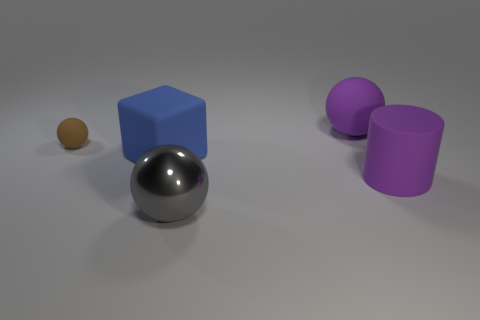Are there any other things that have the same material as the gray thing? Upon inspecting the image, it appears that the gray sphere has a reflective surface, resembling a polished metal. There are no other objects in the image that share the same metallic characteristics. The other objects possess more matte surfaces indicating they are likely made from different materials like plastic or ceramic. 